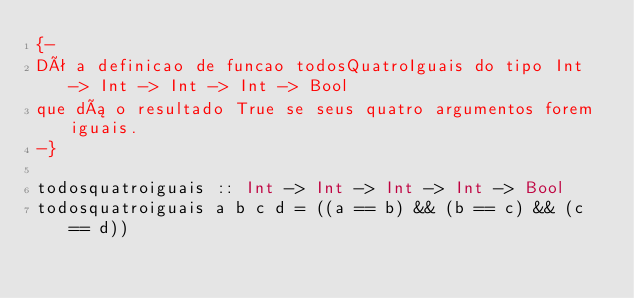<code> <loc_0><loc_0><loc_500><loc_500><_Haskell_>{-
Dê a definicao de funcao todosQuatroIguais do tipo Int -> Int -> Int -> Int -> Bool
que dá o resultado True se seus quatro argumentos forem iguais.
-}

todosquatroiguais :: Int -> Int -> Int -> Int -> Bool
todosquatroiguais a b c d = ((a == b) && (b == c) && (c == d))</code> 